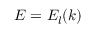Convert formula to latex. <formula><loc_0><loc_0><loc_500><loc_500>E = E _ { l } ( k )</formula> 